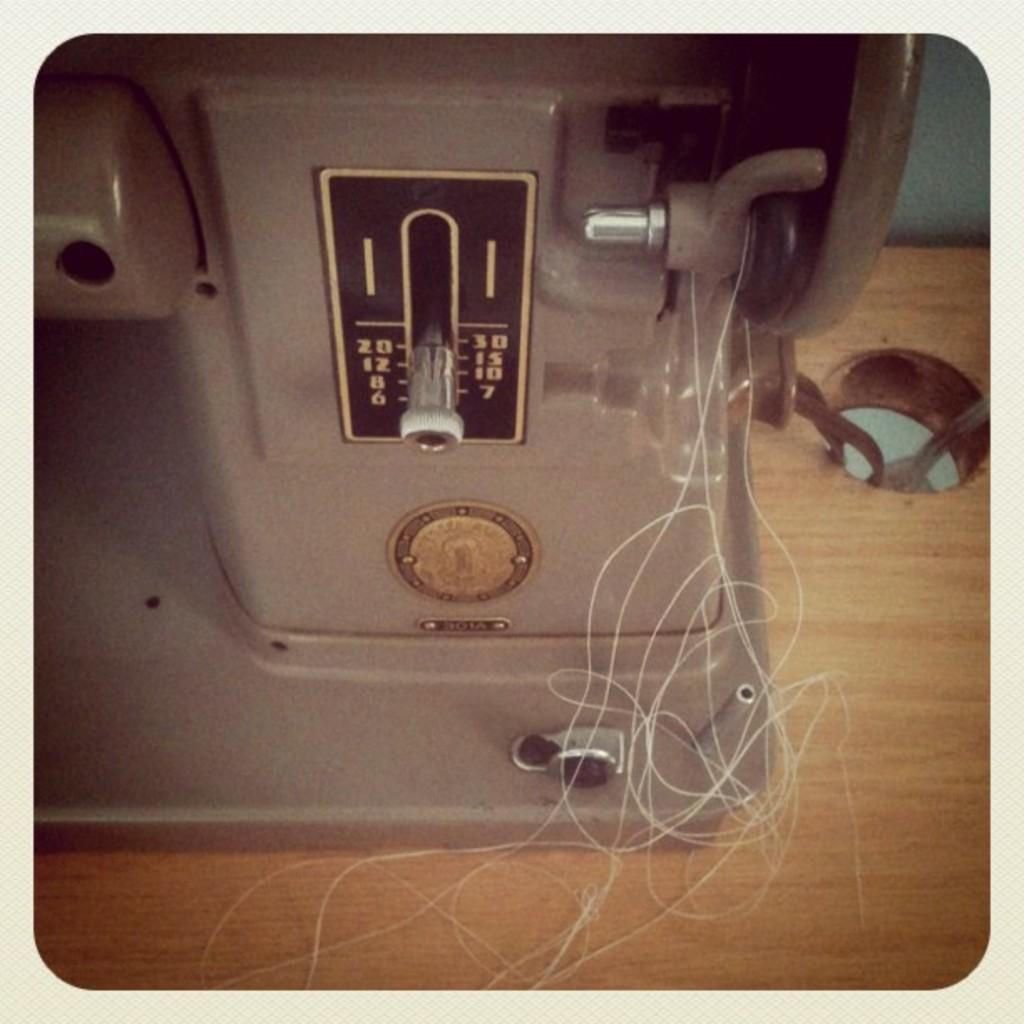What is the main object in the image? There is a sieving machine in the image. Where is the sieving machine located? The sieving machine is on a table. What else can be seen in the image besides the sieving machine? There is thread visible in the image. What reward does the sieving machine receive for its work in the image? There is no indication of a reward system for the sieving machine in the image. 